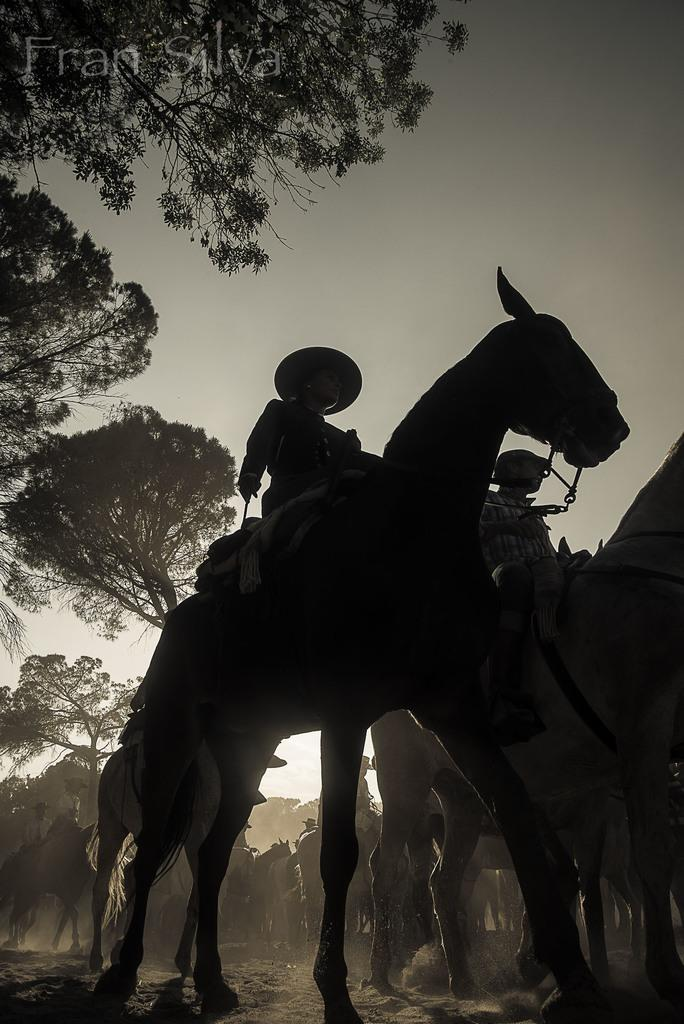What is the person in the image wearing on their head? The person in the image is wearing a hat. What is the person doing in the image? The person is sitting on a horse. Can you describe the background of the image? There are people sitting on horses, trees, and the sky visible in the background of the image. What type of surface is visible in the image? There is ground visible in the image. Can you tell me how many bees are buzzing around the person's hat in the image? There are no bees visible in the image; the person is wearing a hat, but there are no bees buzzing around it. What type of approval is the beggar seeking from the person on the horse in the image? There is no beggar present in the image, so it is not possible to determine what type of approval they might be seeking. 